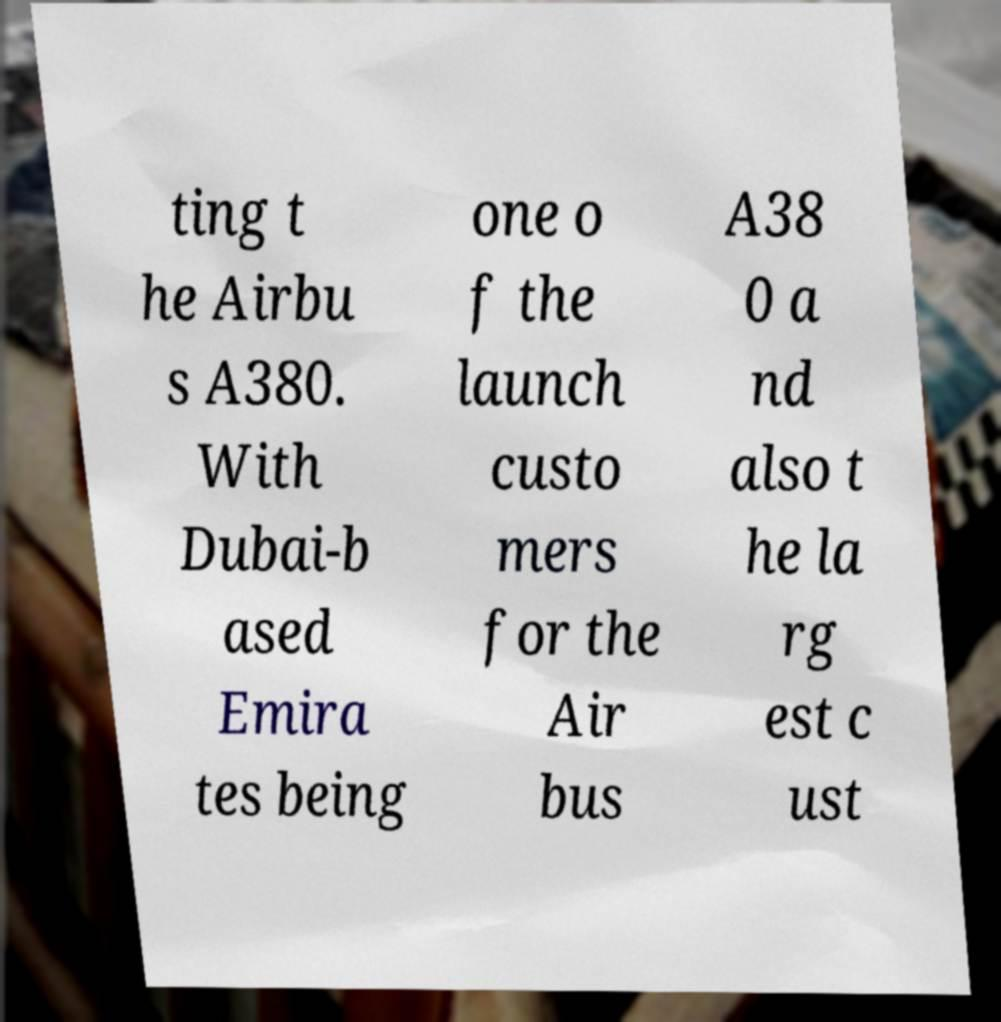Please identify and transcribe the text found in this image. ting t he Airbu s A380. With Dubai-b ased Emira tes being one o f the launch custo mers for the Air bus A38 0 a nd also t he la rg est c ust 